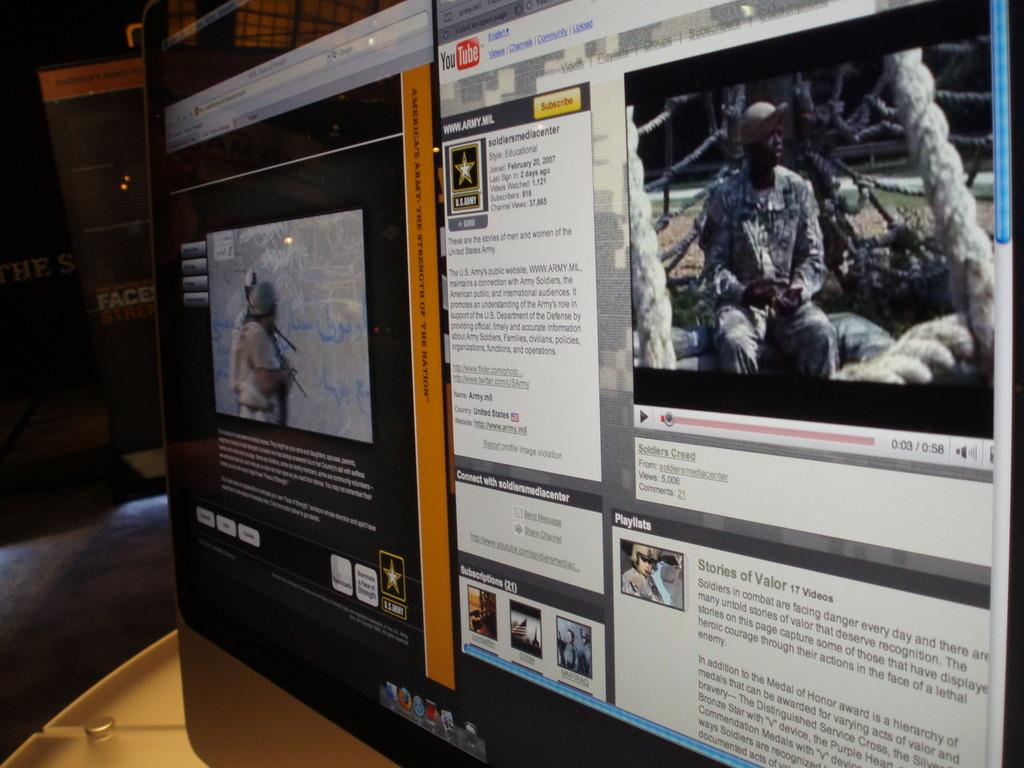<image>
Present a compact description of the photo's key features. A split screen with YouTube in the top right corner and Army on one of the screen. 